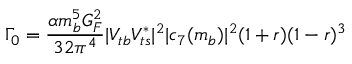Convert formula to latex. <formula><loc_0><loc_0><loc_500><loc_500>\Gamma _ { 0 } = \frac { \alpha m _ { b } ^ { 5 } G _ { F } ^ { 2 } } { 3 2 \pi ^ { 4 } } | V _ { t b } V _ { t s } ^ { * } | ^ { 2 } | c _ { 7 } ( m _ { b } ) | ^ { 2 } ( 1 + r ) ( 1 - r ) ^ { 3 }</formula> 